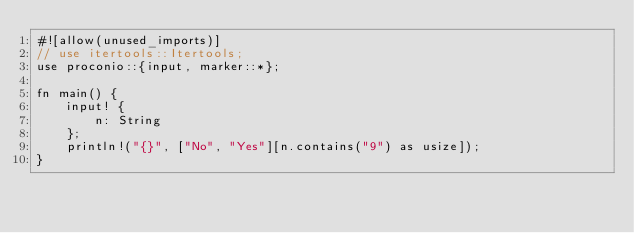Convert code to text. <code><loc_0><loc_0><loc_500><loc_500><_Rust_>#![allow(unused_imports)]
// use itertools::Itertools;
use proconio::{input, marker::*};

fn main() {
    input! {
        n: String
    };
    println!("{}", ["No", "Yes"][n.contains("9") as usize]);
}
</code> 